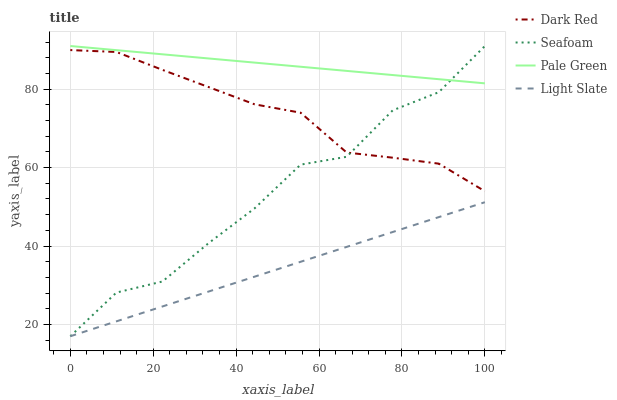Does Dark Red have the minimum area under the curve?
Answer yes or no. No. Does Dark Red have the maximum area under the curve?
Answer yes or no. No. Is Dark Red the smoothest?
Answer yes or no. No. Is Dark Red the roughest?
Answer yes or no. No. Does Dark Red have the lowest value?
Answer yes or no. No. Does Dark Red have the highest value?
Answer yes or no. No. Is Dark Red less than Pale Green?
Answer yes or no. Yes. Is Pale Green greater than Light Slate?
Answer yes or no. Yes. Does Dark Red intersect Pale Green?
Answer yes or no. No. 